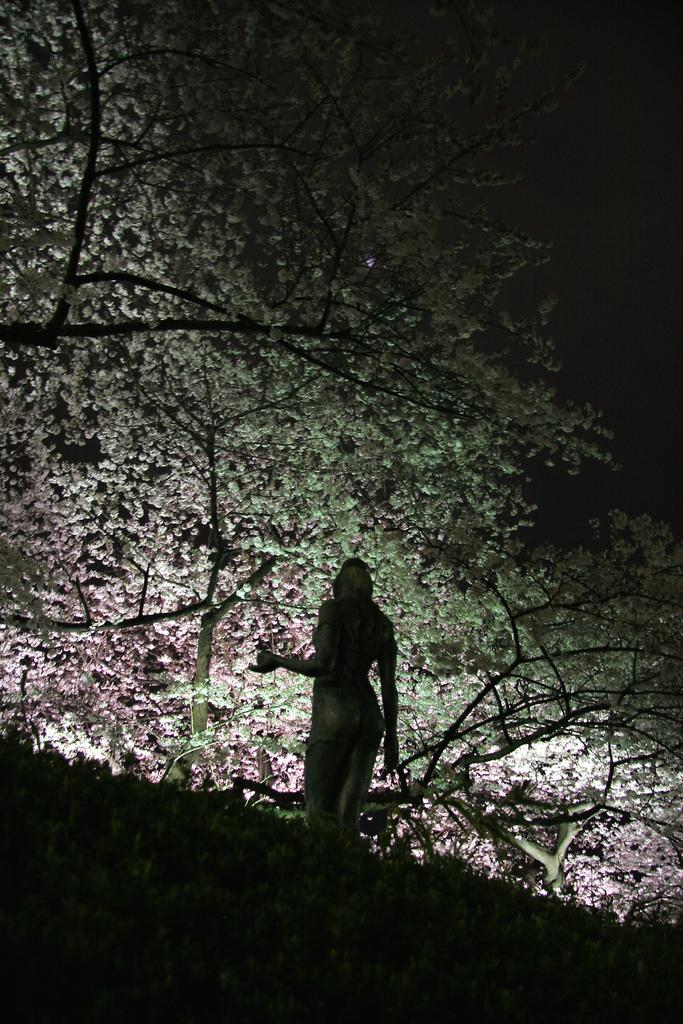What is the main subject in the image? There is a person sculpture in the image. What type of natural vegetation is present in the image? There are trees in the image. What is the condition of the sky in the background of the image? The sky is dark in the background of the image. What type of scent can be smelled coming from the zebra in the image? There is no zebra present in the image, so it is not possible to determine what scent might be associated with it. 